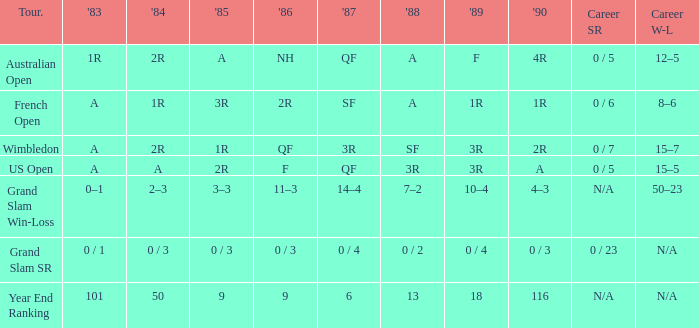What happened in 1985 when the career win-loss was not provided and the career sr was 0 out of 23? 0 / 3. Could you parse the entire table? {'header': ['Tour.', "'83", "'84", "'85", "'86", "'87", "'88", "'89", "'90", 'Career SR', 'Career W-L'], 'rows': [['Australian Open', '1R', '2R', 'A', 'NH', 'QF', 'A', 'F', '4R', '0 / 5', '12–5'], ['French Open', 'A', '1R', '3R', '2R', 'SF', 'A', '1R', '1R', '0 / 6', '8–6'], ['Wimbledon', 'A', '2R', '1R', 'QF', '3R', 'SF', '3R', '2R', '0 / 7', '15–7'], ['US Open', 'A', 'A', '2R', 'F', 'QF', '3R', '3R', 'A', '0 / 5', '15–5'], ['Grand Slam Win-Loss', '0–1', '2–3', '3–3', '11–3', '14–4', '7–2', '10–4', '4–3', 'N/A', '50–23'], ['Grand Slam SR', '0 / 1', '0 / 3', '0 / 3', '0 / 3', '0 / 4', '0 / 2', '0 / 4', '0 / 3', '0 / 23', 'N/A'], ['Year End Ranking', '101', '50', '9', '9', '6', '13', '18', '116', 'N/A', 'N/A']]} 